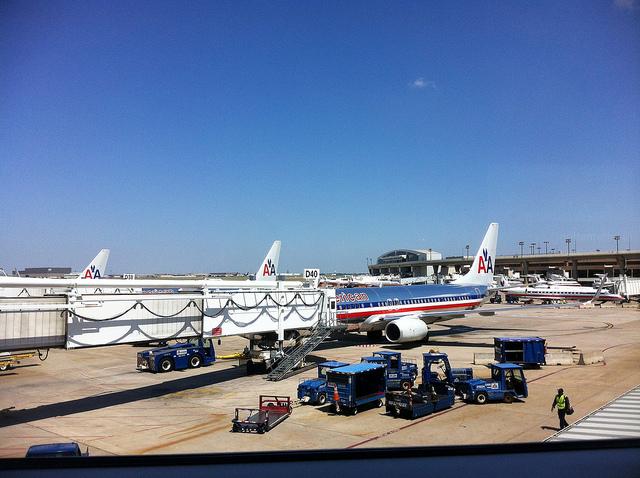Is the plane currently flying?
Give a very brief answer. No. What are the double letters on the plane?
Write a very short answer. Aa. What colors are on the frontmost plane?
Keep it brief. Red, white and blue. Is the sky cloudy?
Be succinct. No. Are there any clouds in the sky?
Answer briefly. Yes. 